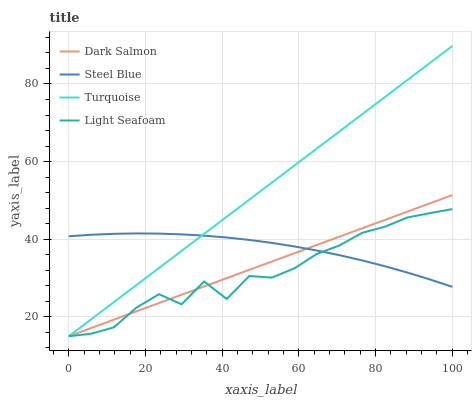Does Light Seafoam have the minimum area under the curve?
Answer yes or no. Yes. Does Turquoise have the maximum area under the curve?
Answer yes or no. Yes. Does Dark Salmon have the minimum area under the curve?
Answer yes or no. No. Does Dark Salmon have the maximum area under the curve?
Answer yes or no. No. Is Dark Salmon the smoothest?
Answer yes or no. Yes. Is Light Seafoam the roughest?
Answer yes or no. Yes. Is Light Seafoam the smoothest?
Answer yes or no. No. Is Dark Salmon the roughest?
Answer yes or no. No. Does Turquoise have the lowest value?
Answer yes or no. Yes. Does Steel Blue have the lowest value?
Answer yes or no. No. Does Turquoise have the highest value?
Answer yes or no. Yes. Does Light Seafoam have the highest value?
Answer yes or no. No. Does Steel Blue intersect Light Seafoam?
Answer yes or no. Yes. Is Steel Blue less than Light Seafoam?
Answer yes or no. No. Is Steel Blue greater than Light Seafoam?
Answer yes or no. No. 